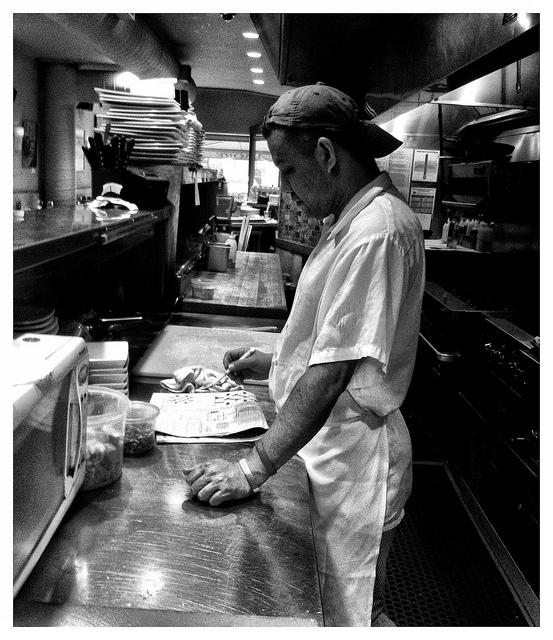What is this person's likely job title?

Choices:
A) garbage man
B) electrician
C) waiter
D) line cook line cook 